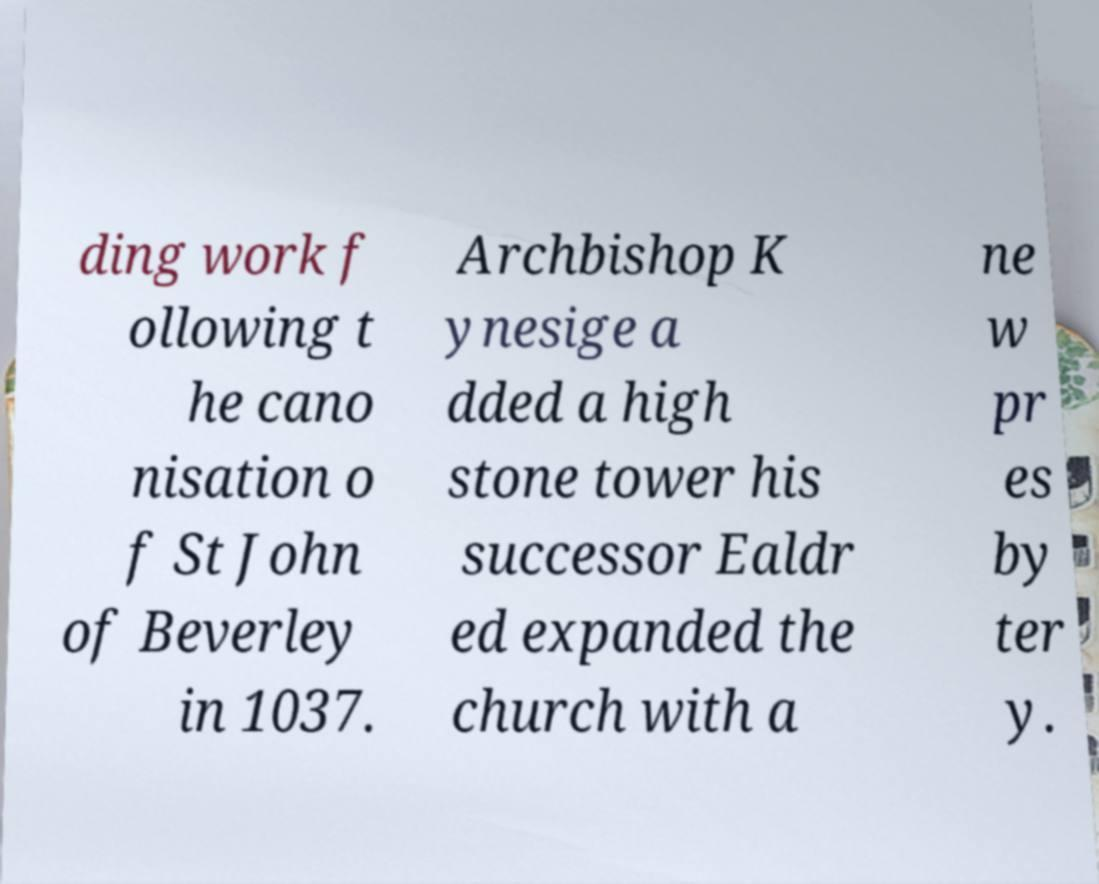There's text embedded in this image that I need extracted. Can you transcribe it verbatim? ding work f ollowing t he cano nisation o f St John of Beverley in 1037. Archbishop K ynesige a dded a high stone tower his successor Ealdr ed expanded the church with a ne w pr es by ter y. 